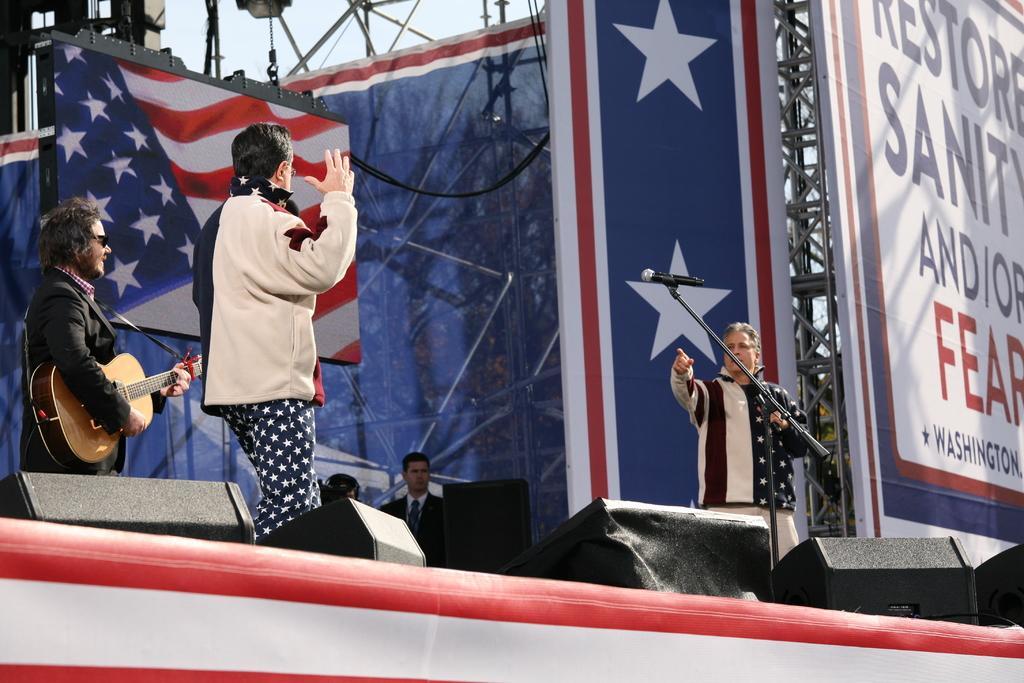Please provide a concise description of this image. The person wearing black suit in the left corner is playing guitar and the person beside him is standing and the person in the right corner is holding a mic in his hand and there are banners behind them. 